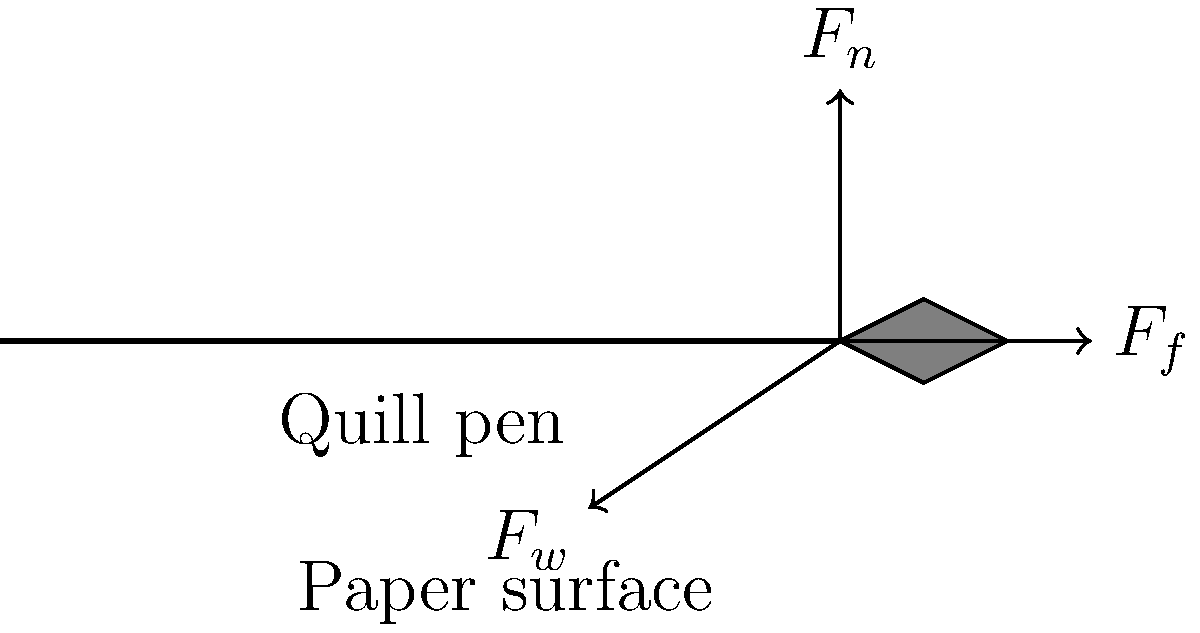Consider the biomechanical forces acting on a quill pen during 17th-century writing. The diagram shows three main forces: the normal force ($F_n$), the friction force ($F_f$), and the writer's applied force ($F_w$). Assuming the pen is moving at a constant velocity across the paper, which of these forces are equal in magnitude? To answer this question, we need to consider the principles of equilibrium in biomechanics:

1. For an object to move at constant velocity, the net force acting on it must be zero (Newton's First Law).

2. The forces acting on the quill pen are:
   a) $F_n$: Normal force from the paper, acting perpendicular to the surface
   b) $F_f$: Friction force from the paper, acting parallel to the surface and opposite to the direction of motion
   c) $F_w$: Writer's applied force, at an angle to the paper surface

3. For horizontal equilibrium: The horizontal component of $F_w$ must equal $F_f$ to maintain constant velocity.

4. For vertical equilibrium: The vertical component of $F_w$ must equal $F_n$ to keep the pen in contact with the paper without piercing it.

5. The writer's applied force $F_w$ can be resolved into its horizontal and vertical components:
   $F_w \cos \theta = F_f$
   $F_w \sin \theta = F_n$

6. Since both of these components are equal to the other forces, we can conclude that $F_f$ and $F_n$ are equal in magnitude to the respective components of $F_w$, but not necessarily to each other.

Therefore, the forces that are equal in magnitude are the friction force ($F_f$) and the horizontal component of the writer's applied force ($F_w \cos \theta$).
Answer: $F_f$ and $F_w \cos \theta$ 